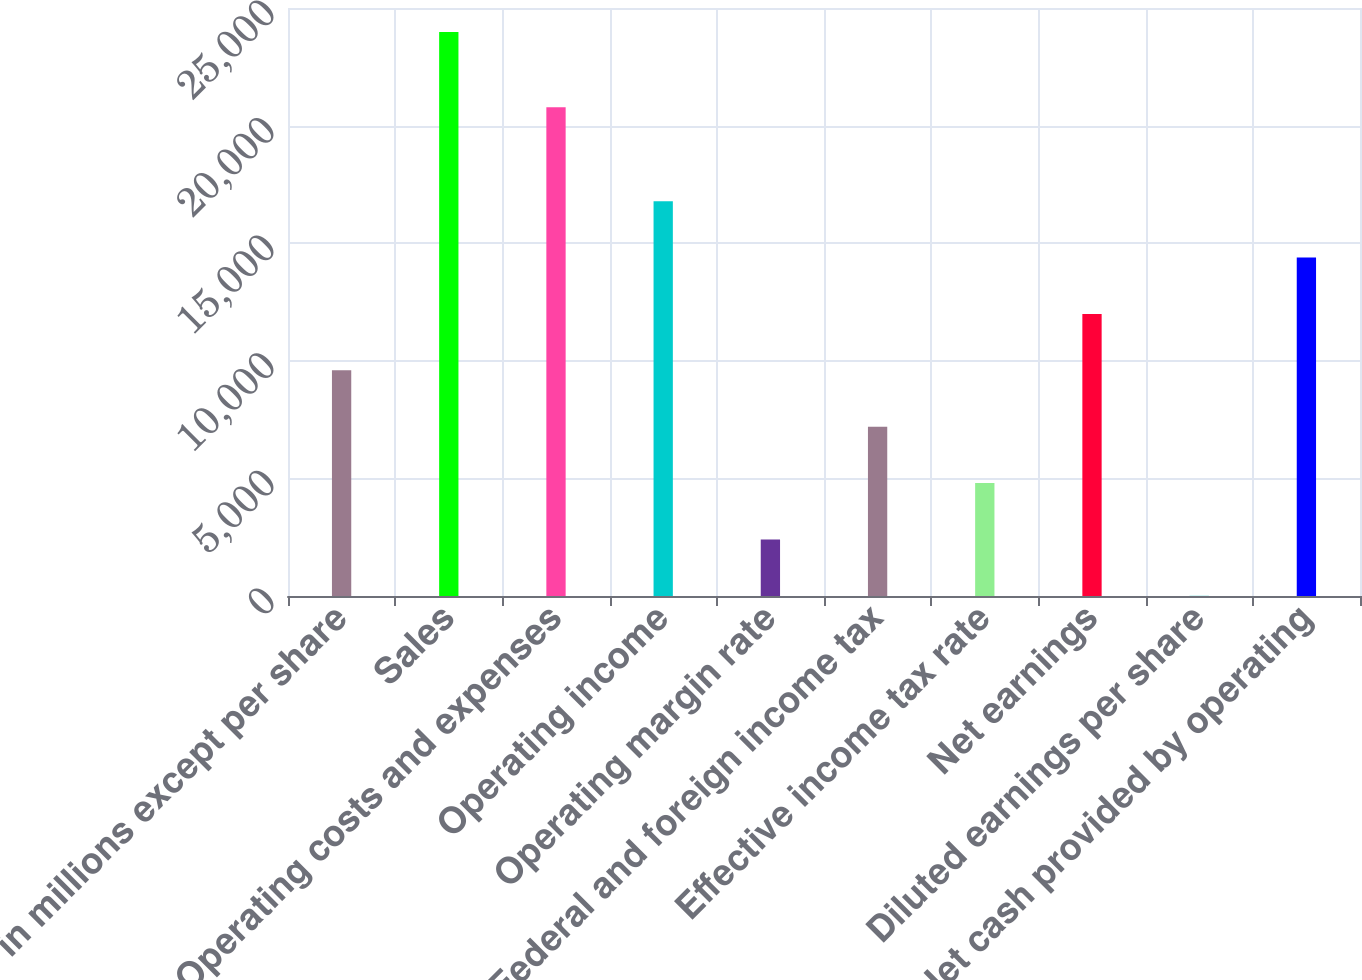Convert chart to OTSL. <chart><loc_0><loc_0><loc_500><loc_500><bar_chart><fcel>in millions except per share<fcel>Sales<fcel>Operating costs and expenses<fcel>Operating income<fcel>Operating margin rate<fcel>Federal and foreign income tax<fcel>Effective income tax rate<fcel>Net earnings<fcel>Diluted earnings per share<fcel>Net cash provided by operating<nl><fcel>9597.45<fcel>23979<fcel>20783<fcel>16788.2<fcel>2406.68<fcel>7200.53<fcel>4803.6<fcel>11994.4<fcel>9.75<fcel>14391.3<nl></chart> 